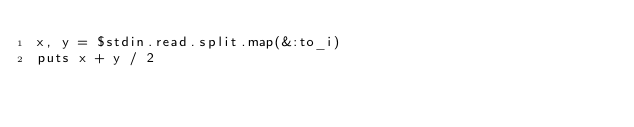<code> <loc_0><loc_0><loc_500><loc_500><_Ruby_>x, y = $stdin.read.split.map(&:to_i)
puts x + y / 2
</code> 